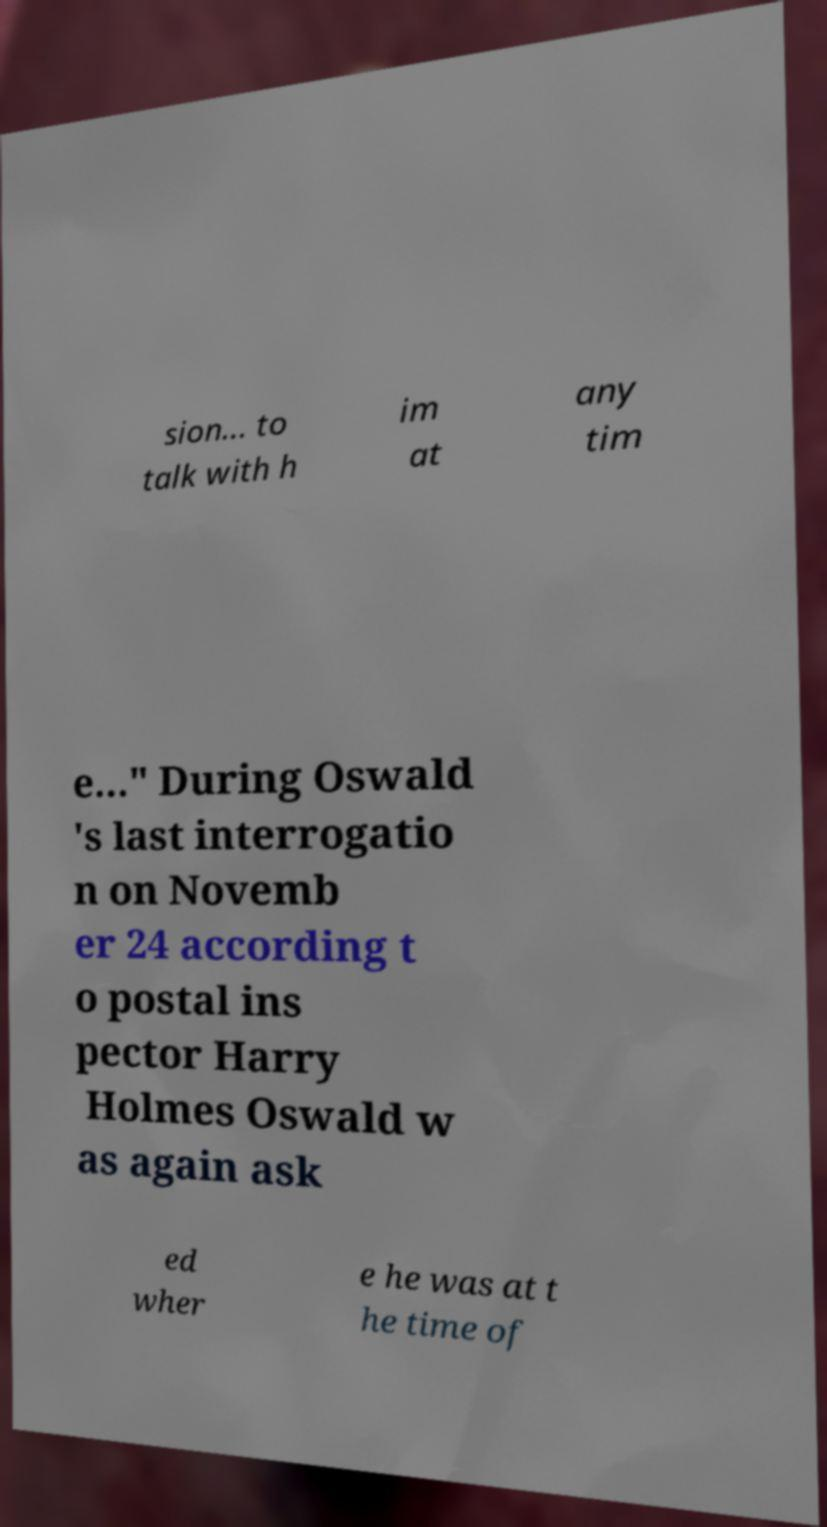Can you accurately transcribe the text from the provided image for me? sion... to talk with h im at any tim e..." During Oswald 's last interrogatio n on Novemb er 24 according t o postal ins pector Harry Holmes Oswald w as again ask ed wher e he was at t he time of 